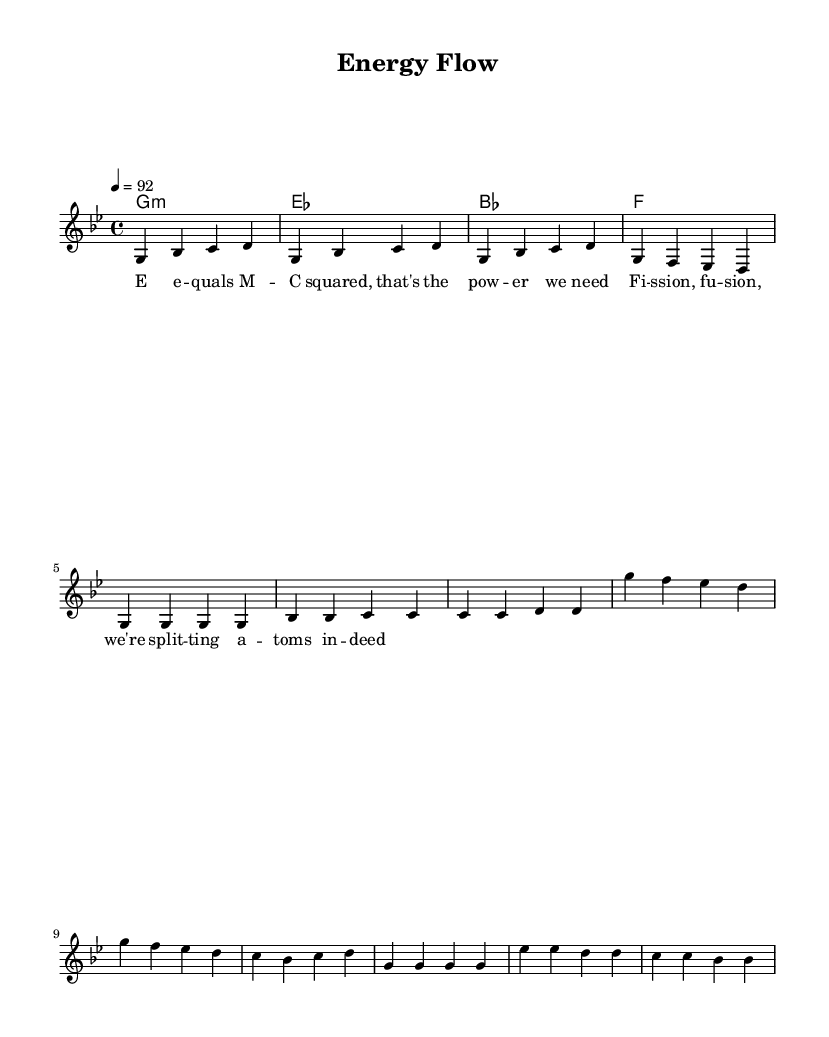What is the key signature of this music? The key signature indicates the use of G minor, which consists of two flats in the notation. The key signature symbol appears at the beginning of the staff.
Answer: G minor What is the time signature of this music? The time signature is found at the beginning of the score, represented as 4/4, indicating four beats in a measure, with a quarter note receiving one beat.
Answer: 4/4 What is the tempo marking of the piece? The tempo marking is shown in the score, stating "4 = 92", which means that there are 92 beats per minute when counting quarter notes. This gives the feel of the pace at which the piece should be performed.
Answer: 92 How many measures are in the verse section? The verse section consists of a sequence of measures, counting each one adds up to a total of 4 measures, which showcase a repeated phrase characteristic of hip hop structure.
Answer: 4 What type of rhyme scheme is reflected in the lyrics? The lyrics follow a simple and direct rhyme scheme often seen in hip hop, where each end phrase corresponds with the line before it, simplifying to AA rhyme in the contexts of the couplets.
Answer: AA How do the phrases in the chorus differ from the verses? The phrases in the chorus contain accompanying selections that create a rhythmic hook, contrasting with the verses’ more lyrical and descriptive text, emphasizing the thematic content of energy and physics.
Answer: More rhythmic What scientific concept is referenced in the lyrics? The lyrics explicitly mention "C squared," referring to Einstein's equation regarding energy and mass (E=mc²), connecting scientific terminology with the theme of energy production and conservation in this hip hop track.
Answer: C squared 